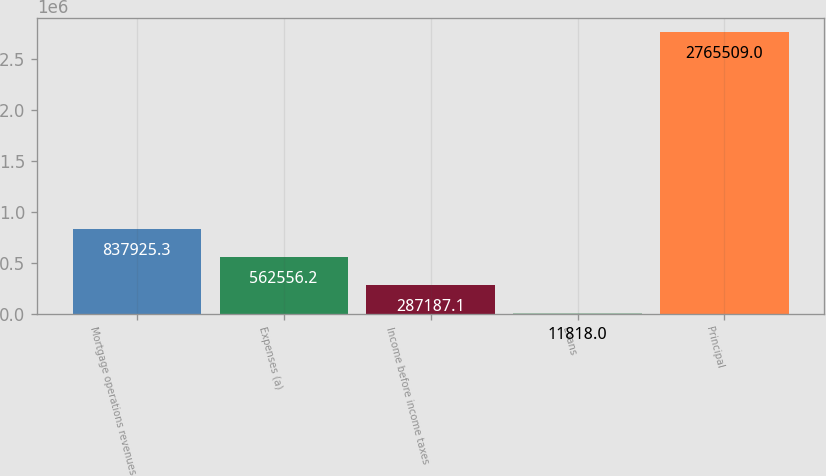Convert chart. <chart><loc_0><loc_0><loc_500><loc_500><bar_chart><fcel>Mortgage operations revenues<fcel>Expenses (a)<fcel>Income before income taxes<fcel>Loans<fcel>Principal<nl><fcel>837925<fcel>562556<fcel>287187<fcel>11818<fcel>2.76551e+06<nl></chart> 